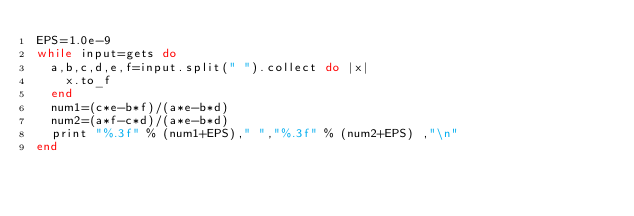<code> <loc_0><loc_0><loc_500><loc_500><_Ruby_>EPS=1.0e-9
while input=gets do
  a,b,c,d,e,f=input.split(" ").collect do |x|
    x.to_f
  end
  num1=(c*e-b*f)/(a*e-b*d)
  num2=(a*f-c*d)/(a*e-b*d)
  print "%.3f" % (num1+EPS)," ","%.3f" % (num2+EPS) ,"\n"
end</code> 